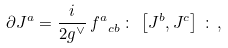Convert formula to latex. <formula><loc_0><loc_0><loc_500><loc_500>\partial J ^ { a } = \frac { i } { 2 g ^ { \vee } } \, { f ^ { a } } _ { c b } \, \colon \, \left [ J ^ { b } , J ^ { c } \right ] \, \colon \, ,</formula> 